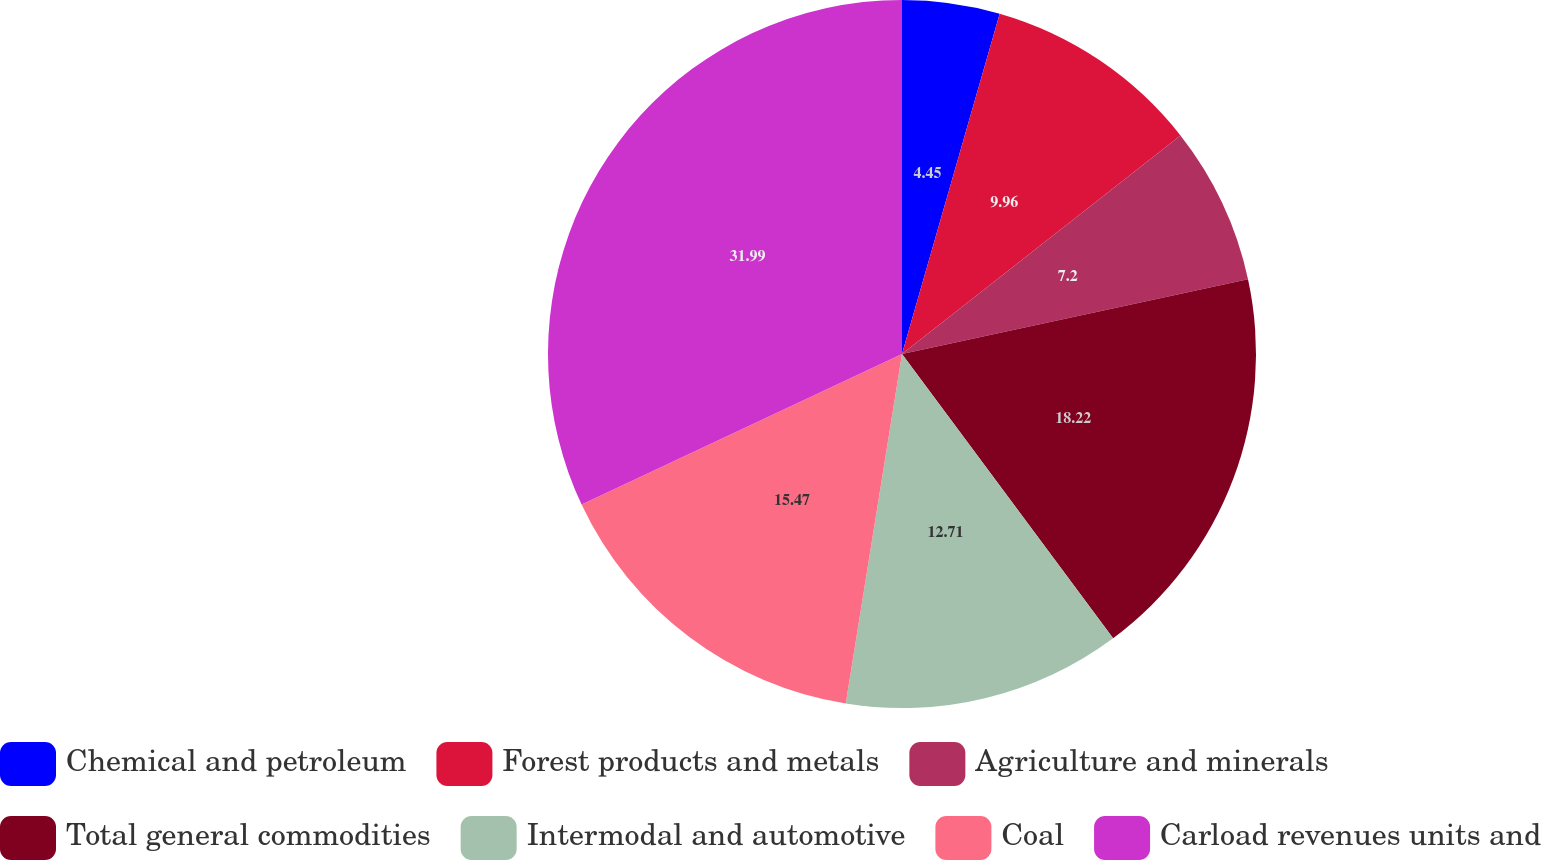Convert chart to OTSL. <chart><loc_0><loc_0><loc_500><loc_500><pie_chart><fcel>Chemical and petroleum<fcel>Forest products and metals<fcel>Agriculture and minerals<fcel>Total general commodities<fcel>Intermodal and automotive<fcel>Coal<fcel>Carload revenues units and<nl><fcel>4.45%<fcel>9.96%<fcel>7.2%<fcel>18.22%<fcel>12.71%<fcel>15.47%<fcel>31.99%<nl></chart> 